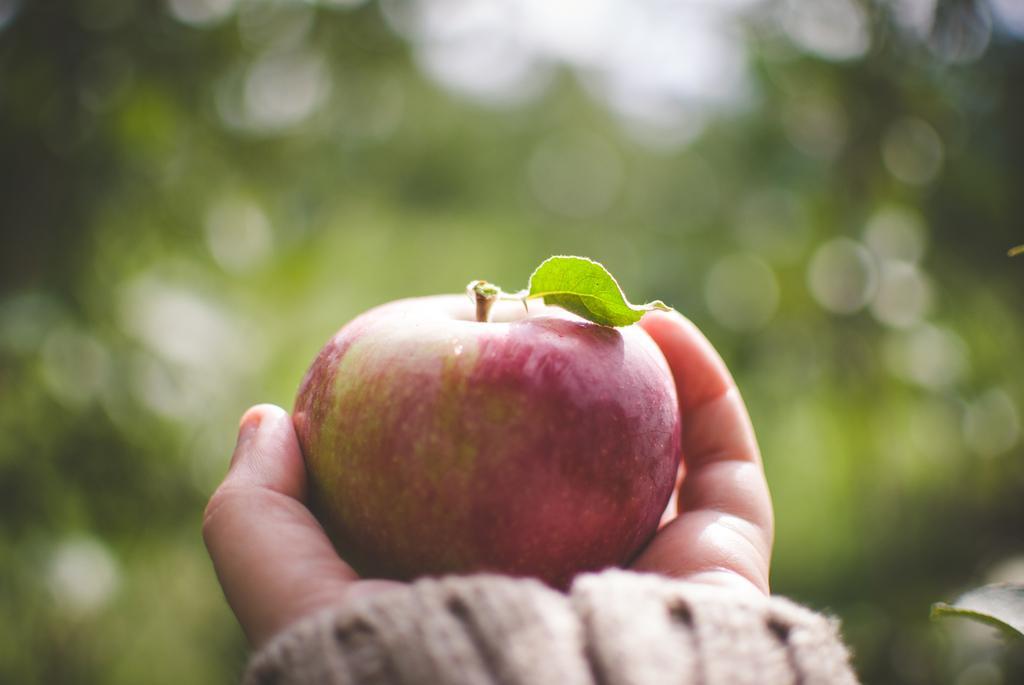In one or two sentences, can you explain what this image depicts? In this image we can see a person's hand holding an apple. The background of the image is blurred. 